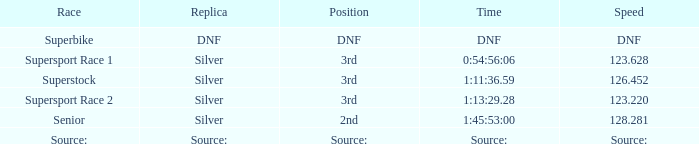Which race has a replica of DNF? Superbike. 